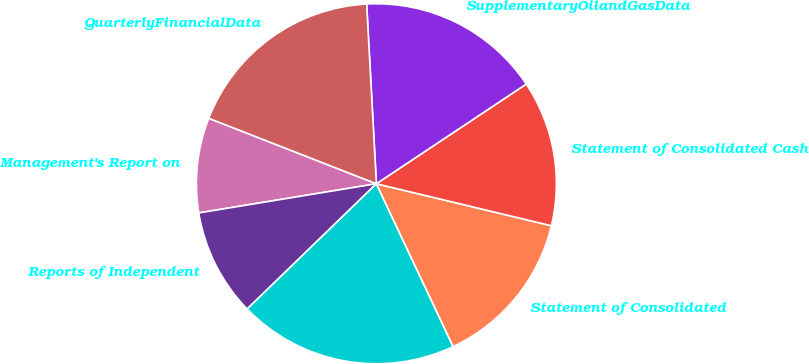Convert chart to OTSL. <chart><loc_0><loc_0><loc_500><loc_500><pie_chart><fcel>Management's Report on<fcel>Reports of Independent<fcel>Unnamed: 2<fcel>Statement of Consolidated<fcel>Statement of Consolidated Cash<fcel>SupplementaryOilandGasData<fcel>QuarterlyFinancialData<nl><fcel>8.52%<fcel>9.66%<fcel>19.76%<fcel>14.24%<fcel>13.09%<fcel>16.52%<fcel>18.21%<nl></chart> 